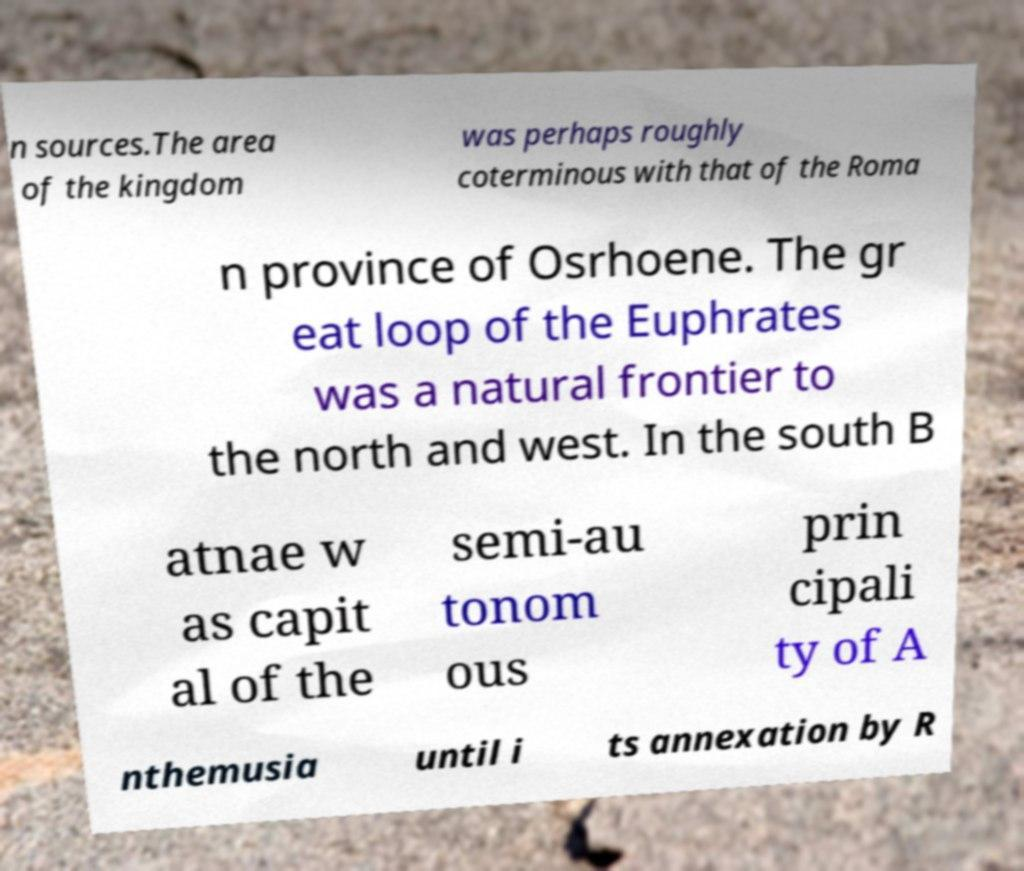Can you accurately transcribe the text from the provided image for me? n sources.The area of the kingdom was perhaps roughly coterminous with that of the Roma n province of Osrhoene. The gr eat loop of the Euphrates was a natural frontier to the north and west. In the south B atnae w as capit al of the semi-au tonom ous prin cipali ty of A nthemusia until i ts annexation by R 